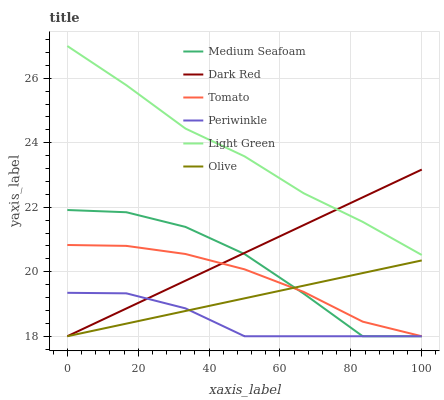Does Periwinkle have the minimum area under the curve?
Answer yes or no. Yes. Does Light Green have the maximum area under the curve?
Answer yes or no. Yes. Does Dark Red have the minimum area under the curve?
Answer yes or no. No. Does Dark Red have the maximum area under the curve?
Answer yes or no. No. Is Dark Red the smoothest?
Answer yes or no. Yes. Is Medium Seafoam the roughest?
Answer yes or no. Yes. Is Periwinkle the smoothest?
Answer yes or no. No. Is Periwinkle the roughest?
Answer yes or no. No. Does Light Green have the lowest value?
Answer yes or no. No. Does Light Green have the highest value?
Answer yes or no. Yes. Does Dark Red have the highest value?
Answer yes or no. No. Is Periwinkle less than Light Green?
Answer yes or no. Yes. Is Light Green greater than Periwinkle?
Answer yes or no. Yes. Does Medium Seafoam intersect Periwinkle?
Answer yes or no. Yes. Is Medium Seafoam less than Periwinkle?
Answer yes or no. No. Is Medium Seafoam greater than Periwinkle?
Answer yes or no. No. Does Periwinkle intersect Light Green?
Answer yes or no. No. 